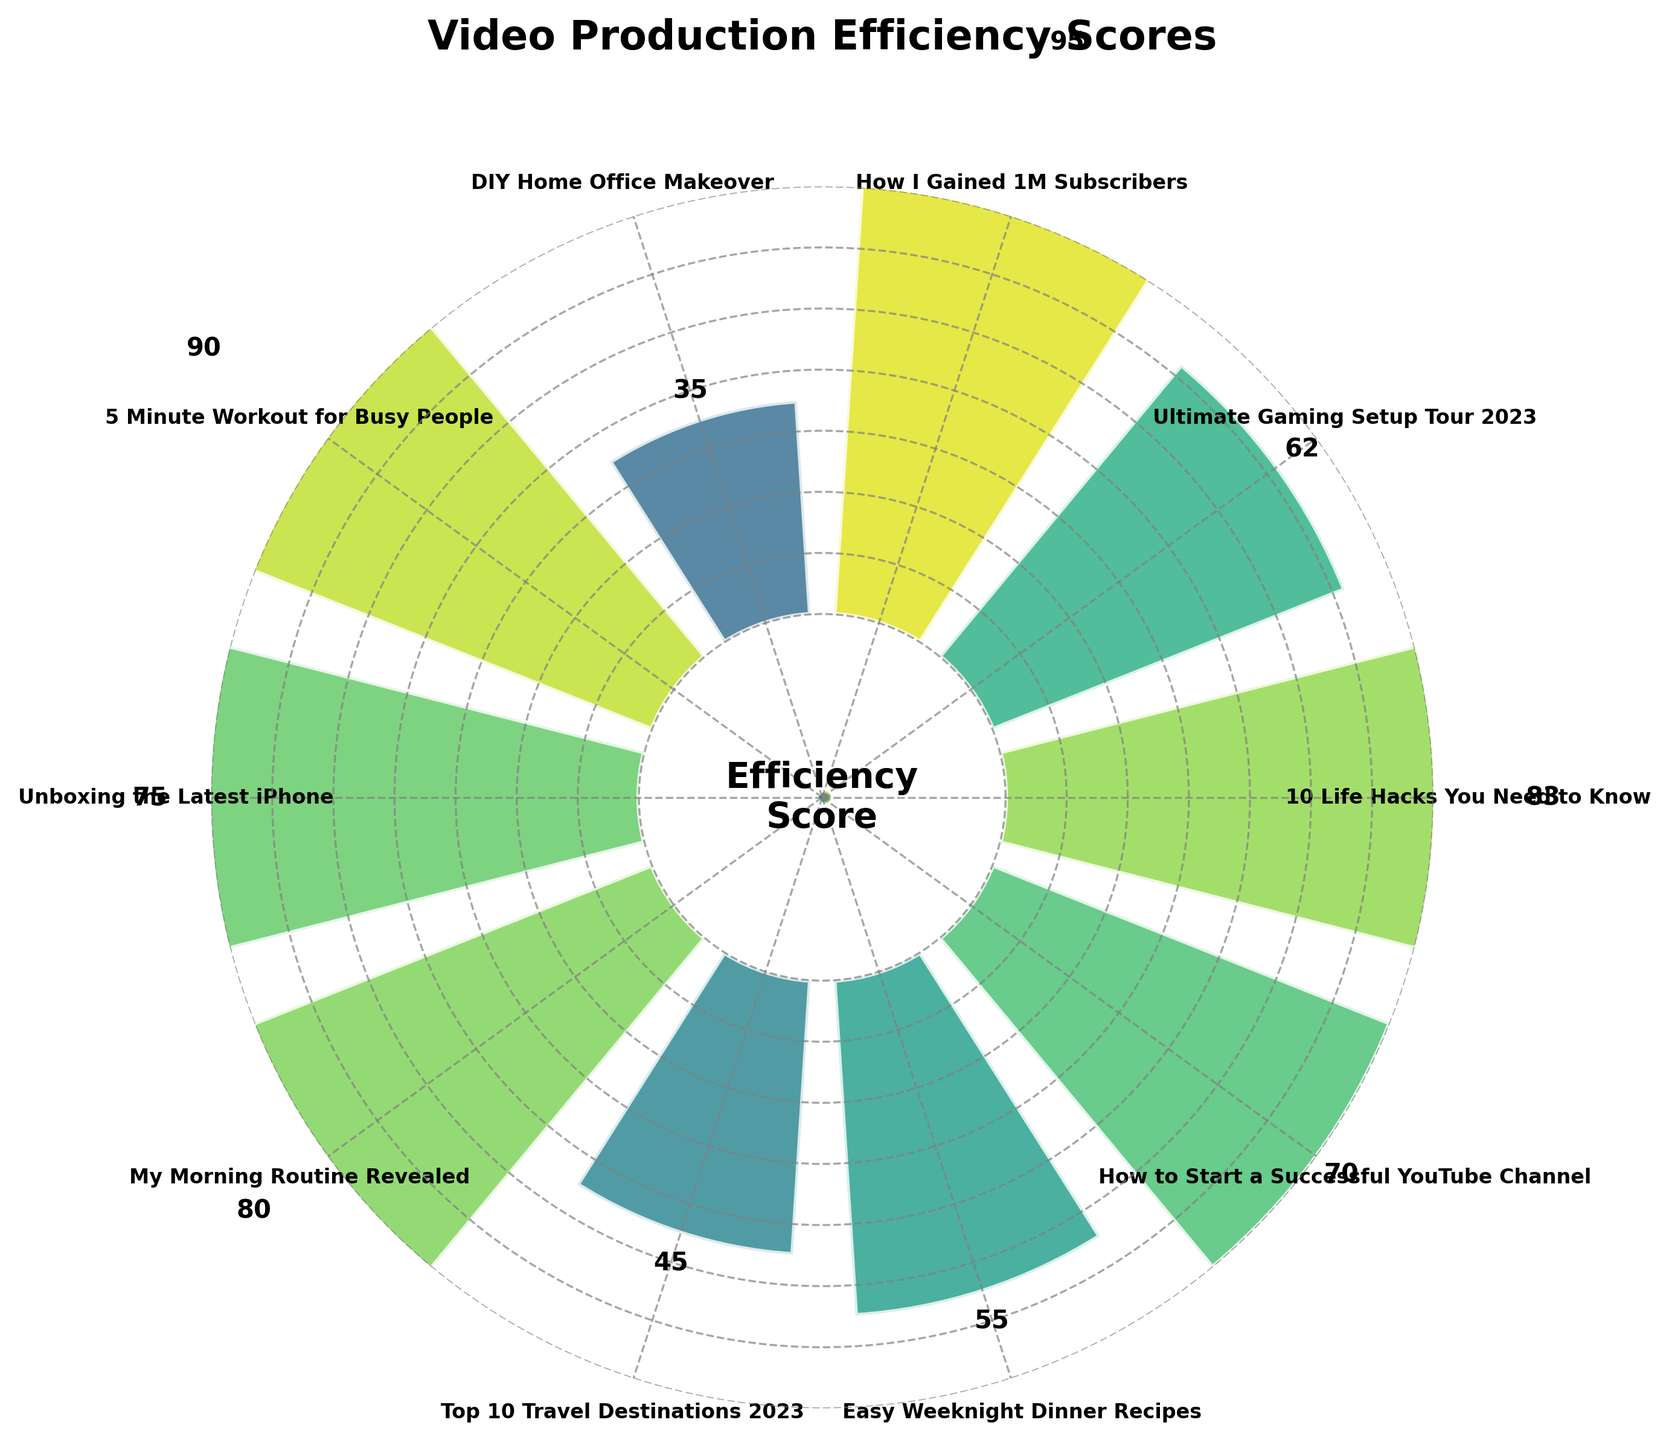What is the title of the figure? The title is placed at the top of the figure as a central text.
Answer: Video Production Efficiency Scores Which video has the highest efficiency score? The highest efficiency score is marked with the maximum value on the gauge.
Answer: "How I Gained 1M Subscribers" Which video has the lowest efficiency score? The lowest efficiency score is marked with the minimum value on the gauge.
Answer: "DIY Home Office Makeover" How many videos have efficiency scores higher than 70? By checking the scores in the figure, count those higher than 70.
Answer: 5 What is the average efficiency score of all videos? Sum the efficiency scores and divide by the number of videos. (83 + 62 + 95 + 35 + 90 + 75 + 80 + 45 + 55 + 70) / 10 = 69
Answer: 69 Which video needed the maximum time invested but has a low efficiency score? Identify the video with maximum hours and check its efficiency score.
Answer: "DIY Home Office Makeover" Compare the efficiency scores of "5 Minute Workout for Busy People" and "Unboxing the Latest iPhone". Which one is higher? Check the scores of both videos and compare.
Answer: "5 Minute Workout for Busy People" What is the difference in efficiency scores between "How I Gained 1M Subscribers" and "Top 10 Travel Destinations 2023"? Subtract the score of "Top 10 Travel Destinations 2023" from the score of "How I Gained 1M Subscribers". 95 - 45 = 50
Answer: 50 